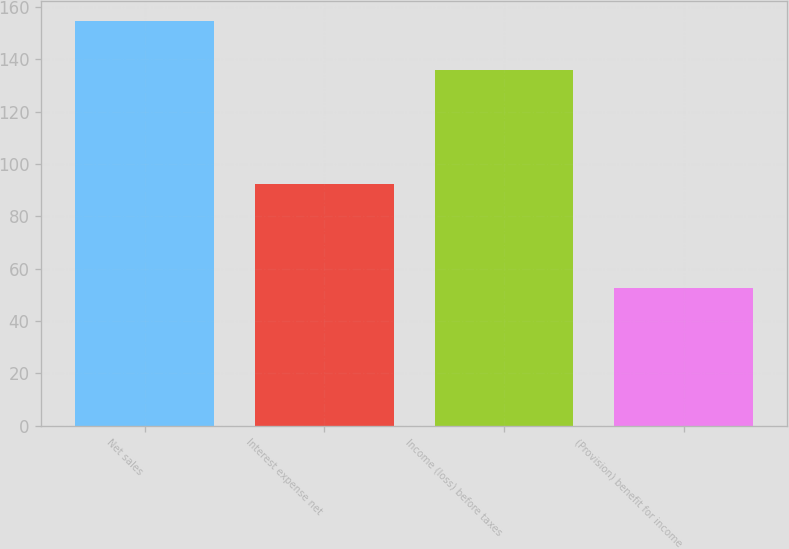Convert chart to OTSL. <chart><loc_0><loc_0><loc_500><loc_500><bar_chart><fcel>Net sales<fcel>Interest expense net<fcel>Income (loss) before taxes<fcel>(Provision) benefit for income<nl><fcel>154.6<fcel>92.2<fcel>135.8<fcel>52.7<nl></chart> 